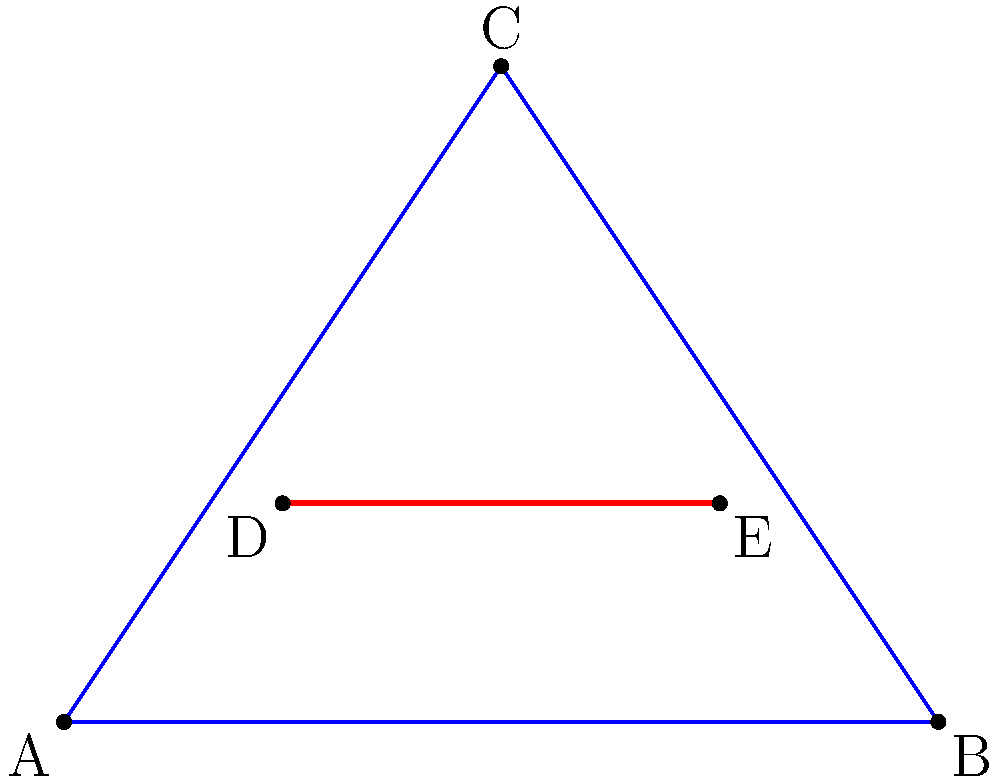A peace monument is designed in the shape of an equilateral triangle with a horizontal beam across its center. If the triangle has a base of 4 meters and a height of 3 meters, at what height above the base should the beam be placed to ensure equal distribution of forces and maintain structural integrity, symbolizing balance and harmony? To find the optimal height for the beam, we need to follow these steps:

1. Recognize that an equilateral triangle has equal sides and angles.

2. The given triangle has a base of 4 meters and a height of 3 meters. This is not a standard equilateral triangle, but we'll work with these dimensions.

3. To ensure equal distribution of forces, the beam should be placed at the centroid of the triangle.

4. For any triangle, the centroid is located at 1/3 of the height from the base.

5. Calculate the height of the beam:
   $h = \frac{1}{3} \times 3\text{ meters} = 1\text{ meter}$

6. This placement ensures that the weight above and below the beam is equally distributed, symbolizing balance and harmony.

7. In the diagram, the red line DE represents the beam at this calculated height.

By placing the beam at this height, we achieve both structural integrity and symbolic meaning for the peace monument.
Answer: 1 meter above the base 